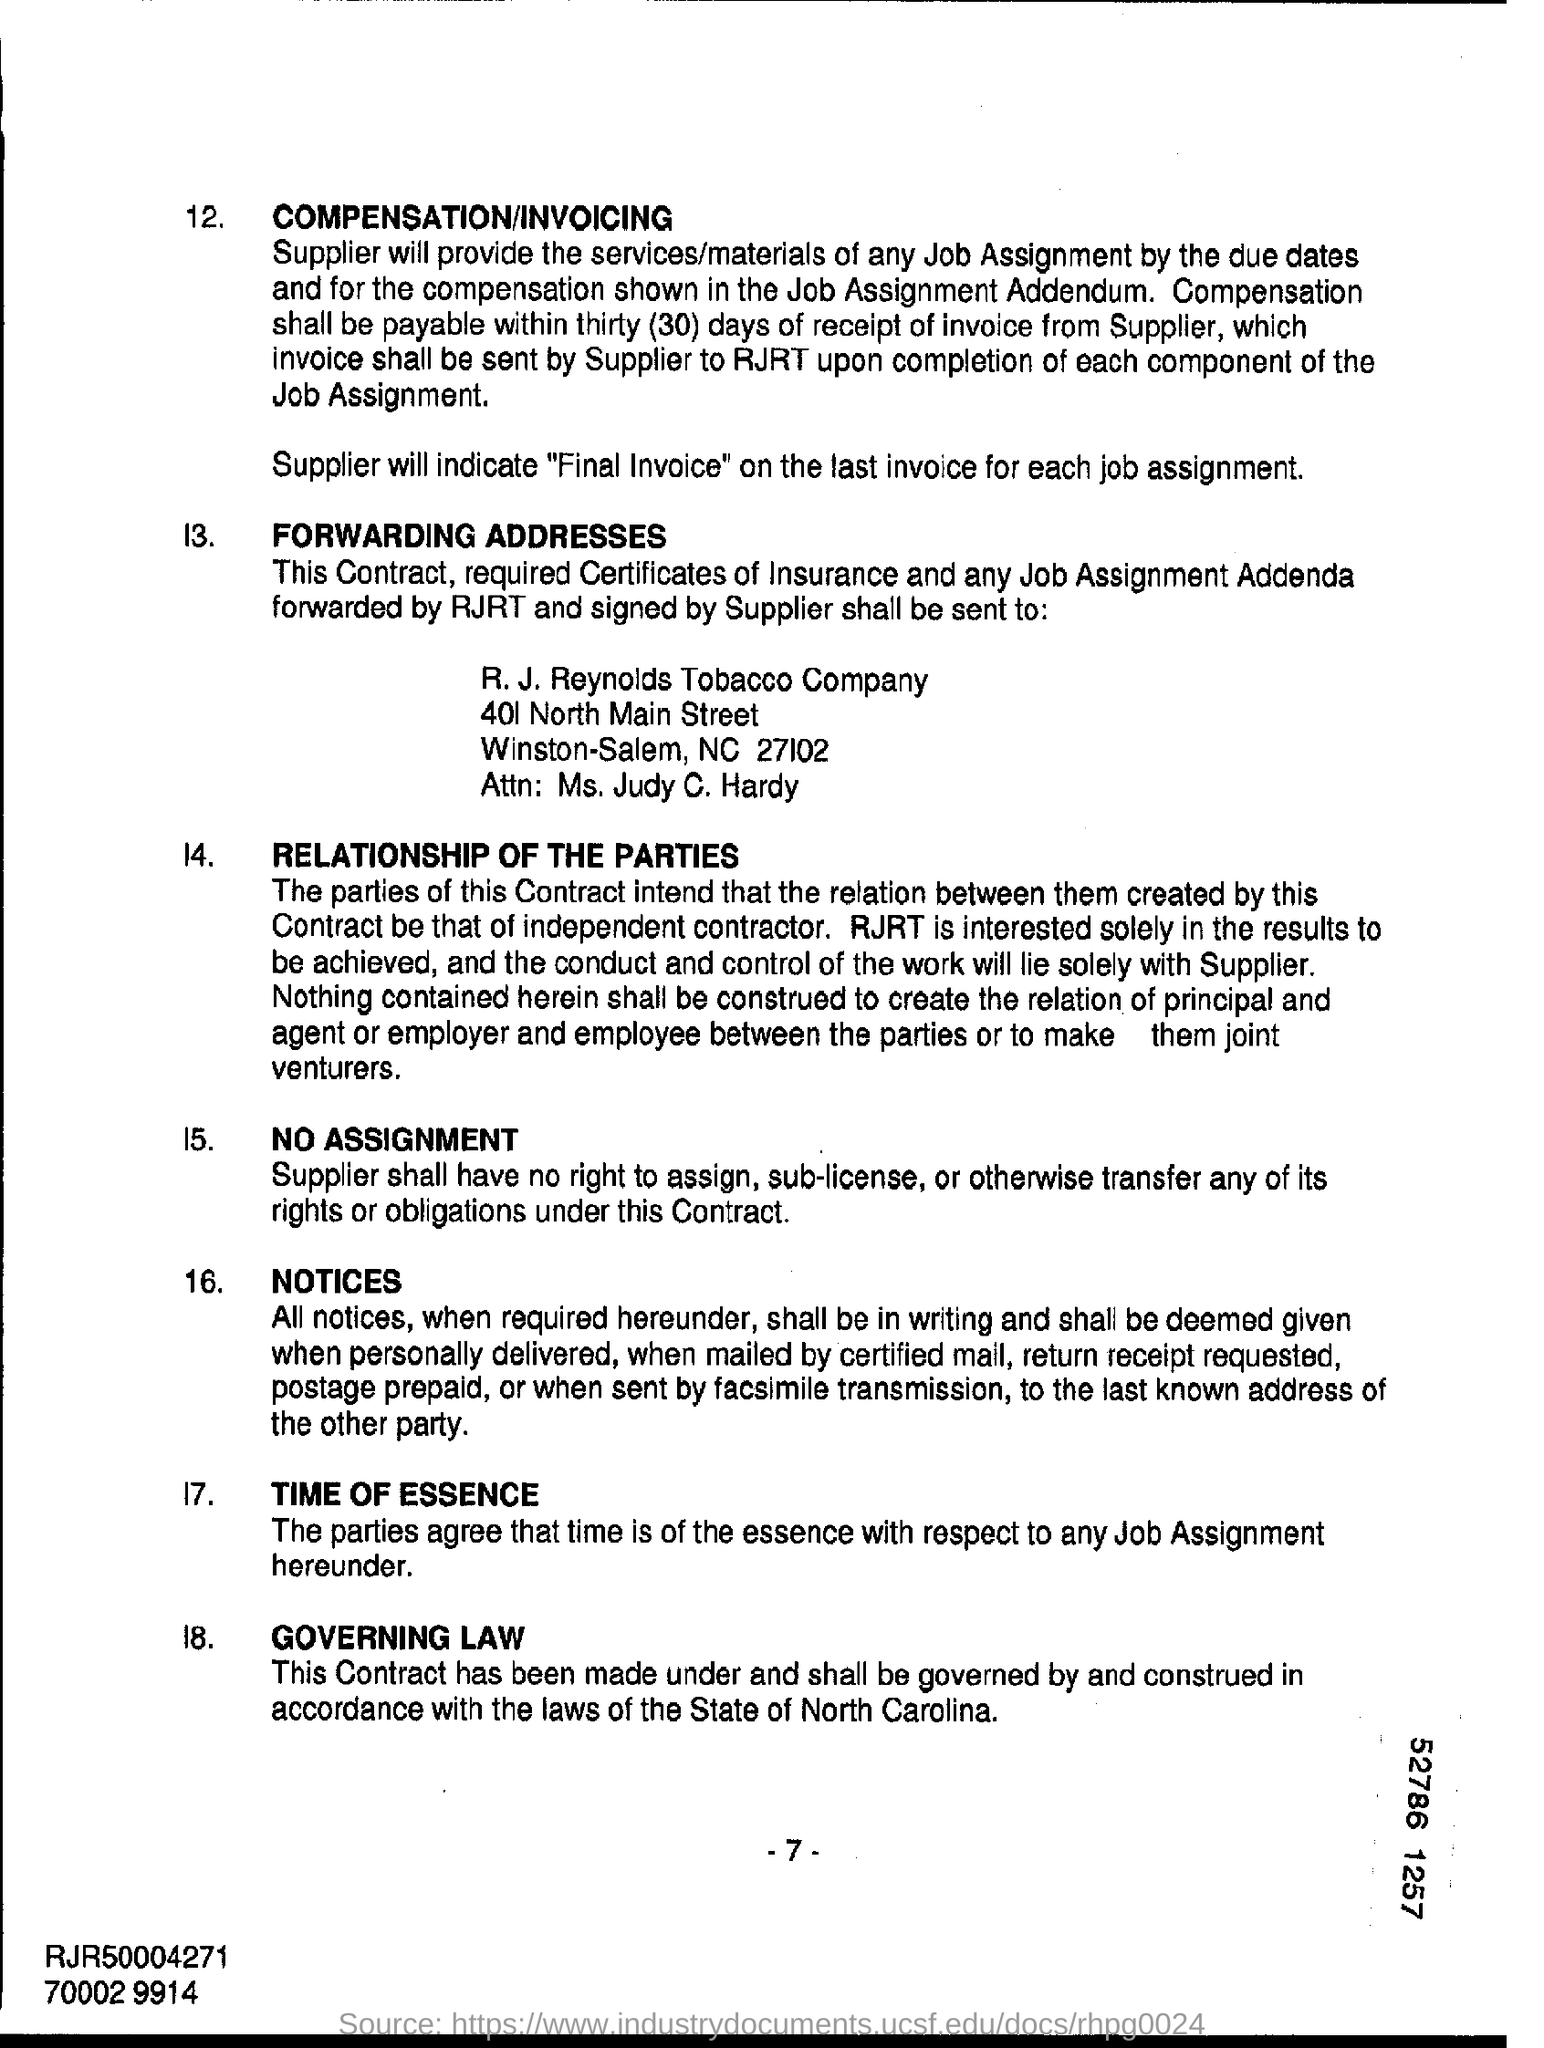Outline some significant characteristics in this image. This contract shall be governed by the laws of the State of North Carolina. R.J. Reynolds Tobacco Company is located in the state of North Carolina. Compensation shall be paid within 30 days, as stated. The supplier will indicate the final invoice on the last invoice for each job assignment. 